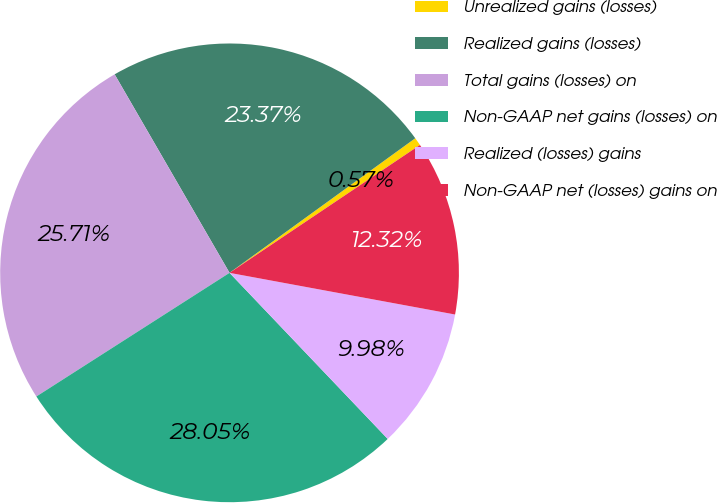Convert chart. <chart><loc_0><loc_0><loc_500><loc_500><pie_chart><fcel>Unrealized gains (losses)<fcel>Realized gains (losses)<fcel>Total gains (losses) on<fcel>Non-GAAP net gains (losses) on<fcel>Realized (losses) gains<fcel>Non-GAAP net (losses) gains on<nl><fcel>0.57%<fcel>23.37%<fcel>25.71%<fcel>28.05%<fcel>9.98%<fcel>12.32%<nl></chart> 